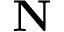<formula> <loc_0><loc_0><loc_500><loc_500>N</formula> 